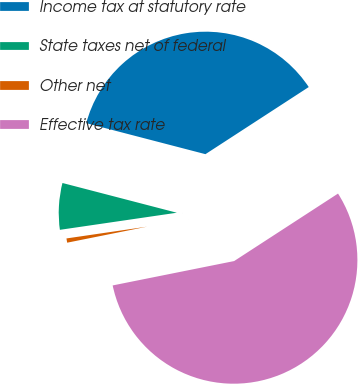<chart> <loc_0><loc_0><loc_500><loc_500><pie_chart><fcel>Income tax at statutory rate<fcel>State taxes net of federal<fcel>Other net<fcel>Effective tax rate<nl><fcel>36.78%<fcel>6.36%<fcel>0.84%<fcel>56.02%<nl></chart> 